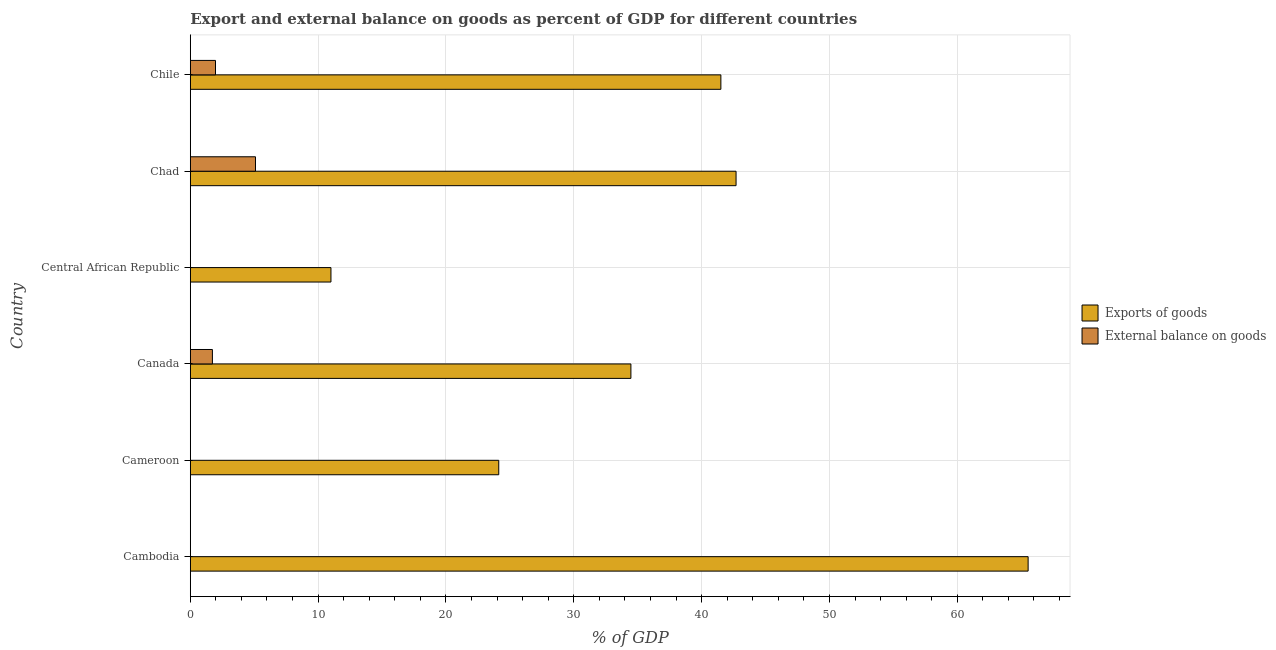Are the number of bars on each tick of the Y-axis equal?
Offer a very short reply. No. How many bars are there on the 1st tick from the bottom?
Offer a very short reply. 1. What is the label of the 4th group of bars from the top?
Your answer should be compact. Canada. In how many cases, is the number of bars for a given country not equal to the number of legend labels?
Your response must be concise. 3. What is the export of goods as percentage of gdp in Cameroon?
Your answer should be compact. 24.13. Across all countries, what is the maximum external balance on goods as percentage of gdp?
Make the answer very short. 5.1. In which country was the external balance on goods as percentage of gdp maximum?
Give a very brief answer. Chad. What is the total external balance on goods as percentage of gdp in the graph?
Offer a terse response. 8.8. What is the difference between the export of goods as percentage of gdp in Central African Republic and that in Chile?
Provide a succinct answer. -30.5. What is the difference between the export of goods as percentage of gdp in Central African Republic and the external balance on goods as percentage of gdp in Chad?
Your answer should be compact. 5.9. What is the average external balance on goods as percentage of gdp per country?
Offer a very short reply. 1.47. What is the difference between the external balance on goods as percentage of gdp and export of goods as percentage of gdp in Chile?
Offer a very short reply. -39.53. What is the ratio of the external balance on goods as percentage of gdp in Canada to that in Chad?
Make the answer very short. 0.34. Is the export of goods as percentage of gdp in Central African Republic less than that in Chad?
Offer a very short reply. Yes. Is the difference between the export of goods as percentage of gdp in Canada and Chad greater than the difference between the external balance on goods as percentage of gdp in Canada and Chad?
Make the answer very short. No. What is the difference between the highest and the second highest export of goods as percentage of gdp?
Give a very brief answer. 22.85. What is the difference between the highest and the lowest export of goods as percentage of gdp?
Give a very brief answer. 54.54. In how many countries, is the external balance on goods as percentage of gdp greater than the average external balance on goods as percentage of gdp taken over all countries?
Your response must be concise. 3. How many bars are there?
Your response must be concise. 9. What is the difference between two consecutive major ticks on the X-axis?
Make the answer very short. 10. Are the values on the major ticks of X-axis written in scientific E-notation?
Keep it short and to the point. No. Does the graph contain any zero values?
Provide a short and direct response. Yes. Does the graph contain grids?
Provide a succinct answer. Yes. Where does the legend appear in the graph?
Offer a terse response. Center right. What is the title of the graph?
Your answer should be very brief. Export and external balance on goods as percent of GDP for different countries. Does "Commercial bank branches" appear as one of the legend labels in the graph?
Your answer should be very brief. No. What is the label or title of the X-axis?
Your response must be concise. % of GDP. What is the % of GDP in Exports of goods in Cambodia?
Keep it short and to the point. 65.54. What is the % of GDP of Exports of goods in Cameroon?
Ensure brevity in your answer.  24.13. What is the % of GDP of External balance on goods in Cameroon?
Your answer should be compact. 0. What is the % of GDP in Exports of goods in Canada?
Your response must be concise. 34.47. What is the % of GDP of External balance on goods in Canada?
Ensure brevity in your answer.  1.73. What is the % of GDP of Exports of goods in Central African Republic?
Provide a short and direct response. 11. What is the % of GDP of Exports of goods in Chad?
Offer a very short reply. 42.69. What is the % of GDP in External balance on goods in Chad?
Your answer should be very brief. 5.1. What is the % of GDP in Exports of goods in Chile?
Your answer should be compact. 41.51. What is the % of GDP of External balance on goods in Chile?
Offer a very short reply. 1.97. Across all countries, what is the maximum % of GDP of Exports of goods?
Provide a succinct answer. 65.54. Across all countries, what is the maximum % of GDP of External balance on goods?
Provide a succinct answer. 5.1. Across all countries, what is the minimum % of GDP of Exports of goods?
Your answer should be compact. 11. What is the total % of GDP in Exports of goods in the graph?
Provide a short and direct response. 219.35. What is the total % of GDP in External balance on goods in the graph?
Your response must be concise. 8.8. What is the difference between the % of GDP of Exports of goods in Cambodia and that in Cameroon?
Your response must be concise. 41.41. What is the difference between the % of GDP of Exports of goods in Cambodia and that in Canada?
Offer a terse response. 31.07. What is the difference between the % of GDP in Exports of goods in Cambodia and that in Central African Republic?
Provide a short and direct response. 54.54. What is the difference between the % of GDP in Exports of goods in Cambodia and that in Chad?
Provide a succinct answer. 22.85. What is the difference between the % of GDP of Exports of goods in Cambodia and that in Chile?
Your answer should be very brief. 24.04. What is the difference between the % of GDP of Exports of goods in Cameroon and that in Canada?
Provide a succinct answer. -10.34. What is the difference between the % of GDP in Exports of goods in Cameroon and that in Central African Republic?
Offer a very short reply. 13.13. What is the difference between the % of GDP in Exports of goods in Cameroon and that in Chad?
Ensure brevity in your answer.  -18.56. What is the difference between the % of GDP of Exports of goods in Cameroon and that in Chile?
Ensure brevity in your answer.  -17.38. What is the difference between the % of GDP of Exports of goods in Canada and that in Central African Republic?
Your response must be concise. 23.46. What is the difference between the % of GDP of Exports of goods in Canada and that in Chad?
Give a very brief answer. -8.23. What is the difference between the % of GDP in External balance on goods in Canada and that in Chad?
Provide a succinct answer. -3.37. What is the difference between the % of GDP of Exports of goods in Canada and that in Chile?
Offer a very short reply. -7.04. What is the difference between the % of GDP of External balance on goods in Canada and that in Chile?
Your answer should be very brief. -0.24. What is the difference between the % of GDP of Exports of goods in Central African Republic and that in Chad?
Offer a very short reply. -31.69. What is the difference between the % of GDP in Exports of goods in Central African Republic and that in Chile?
Your answer should be compact. -30.5. What is the difference between the % of GDP of Exports of goods in Chad and that in Chile?
Provide a short and direct response. 1.19. What is the difference between the % of GDP of External balance on goods in Chad and that in Chile?
Offer a terse response. 3.13. What is the difference between the % of GDP of Exports of goods in Cambodia and the % of GDP of External balance on goods in Canada?
Offer a very short reply. 63.81. What is the difference between the % of GDP in Exports of goods in Cambodia and the % of GDP in External balance on goods in Chad?
Your response must be concise. 60.44. What is the difference between the % of GDP in Exports of goods in Cambodia and the % of GDP in External balance on goods in Chile?
Offer a terse response. 63.57. What is the difference between the % of GDP in Exports of goods in Cameroon and the % of GDP in External balance on goods in Canada?
Provide a short and direct response. 22.4. What is the difference between the % of GDP in Exports of goods in Cameroon and the % of GDP in External balance on goods in Chad?
Your answer should be compact. 19.03. What is the difference between the % of GDP of Exports of goods in Cameroon and the % of GDP of External balance on goods in Chile?
Offer a very short reply. 22.16. What is the difference between the % of GDP in Exports of goods in Canada and the % of GDP in External balance on goods in Chad?
Ensure brevity in your answer.  29.37. What is the difference between the % of GDP in Exports of goods in Canada and the % of GDP in External balance on goods in Chile?
Keep it short and to the point. 32.5. What is the difference between the % of GDP in Exports of goods in Central African Republic and the % of GDP in External balance on goods in Chad?
Keep it short and to the point. 5.9. What is the difference between the % of GDP of Exports of goods in Central African Republic and the % of GDP of External balance on goods in Chile?
Keep it short and to the point. 9.03. What is the difference between the % of GDP of Exports of goods in Chad and the % of GDP of External balance on goods in Chile?
Provide a succinct answer. 40.72. What is the average % of GDP in Exports of goods per country?
Provide a short and direct response. 36.56. What is the average % of GDP in External balance on goods per country?
Keep it short and to the point. 1.47. What is the difference between the % of GDP of Exports of goods and % of GDP of External balance on goods in Canada?
Your response must be concise. 32.74. What is the difference between the % of GDP of Exports of goods and % of GDP of External balance on goods in Chad?
Your answer should be very brief. 37.6. What is the difference between the % of GDP of Exports of goods and % of GDP of External balance on goods in Chile?
Your answer should be very brief. 39.53. What is the ratio of the % of GDP in Exports of goods in Cambodia to that in Cameroon?
Give a very brief answer. 2.72. What is the ratio of the % of GDP of Exports of goods in Cambodia to that in Canada?
Give a very brief answer. 1.9. What is the ratio of the % of GDP of Exports of goods in Cambodia to that in Central African Republic?
Make the answer very short. 5.96. What is the ratio of the % of GDP of Exports of goods in Cambodia to that in Chad?
Provide a succinct answer. 1.54. What is the ratio of the % of GDP in Exports of goods in Cambodia to that in Chile?
Provide a short and direct response. 1.58. What is the ratio of the % of GDP of Exports of goods in Cameroon to that in Canada?
Your response must be concise. 0.7. What is the ratio of the % of GDP in Exports of goods in Cameroon to that in Central African Republic?
Make the answer very short. 2.19. What is the ratio of the % of GDP of Exports of goods in Cameroon to that in Chad?
Your response must be concise. 0.57. What is the ratio of the % of GDP of Exports of goods in Cameroon to that in Chile?
Give a very brief answer. 0.58. What is the ratio of the % of GDP of Exports of goods in Canada to that in Central African Republic?
Your answer should be very brief. 3.13. What is the ratio of the % of GDP in Exports of goods in Canada to that in Chad?
Your answer should be very brief. 0.81. What is the ratio of the % of GDP in External balance on goods in Canada to that in Chad?
Make the answer very short. 0.34. What is the ratio of the % of GDP in Exports of goods in Canada to that in Chile?
Your answer should be compact. 0.83. What is the ratio of the % of GDP in External balance on goods in Canada to that in Chile?
Keep it short and to the point. 0.88. What is the ratio of the % of GDP in Exports of goods in Central African Republic to that in Chad?
Ensure brevity in your answer.  0.26. What is the ratio of the % of GDP in Exports of goods in Central African Republic to that in Chile?
Make the answer very short. 0.27. What is the ratio of the % of GDP in Exports of goods in Chad to that in Chile?
Give a very brief answer. 1.03. What is the ratio of the % of GDP in External balance on goods in Chad to that in Chile?
Your answer should be very brief. 2.59. What is the difference between the highest and the second highest % of GDP in Exports of goods?
Make the answer very short. 22.85. What is the difference between the highest and the second highest % of GDP in External balance on goods?
Make the answer very short. 3.13. What is the difference between the highest and the lowest % of GDP of Exports of goods?
Offer a very short reply. 54.54. What is the difference between the highest and the lowest % of GDP of External balance on goods?
Keep it short and to the point. 5.1. 